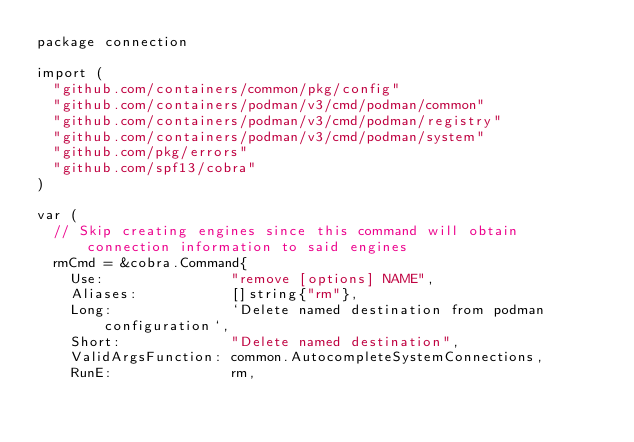<code> <loc_0><loc_0><loc_500><loc_500><_Go_>package connection

import (
	"github.com/containers/common/pkg/config"
	"github.com/containers/podman/v3/cmd/podman/common"
	"github.com/containers/podman/v3/cmd/podman/registry"
	"github.com/containers/podman/v3/cmd/podman/system"
	"github.com/pkg/errors"
	"github.com/spf13/cobra"
)

var (
	// Skip creating engines since this command will obtain connection information to said engines
	rmCmd = &cobra.Command{
		Use:               "remove [options] NAME",
		Aliases:           []string{"rm"},
		Long:              `Delete named destination from podman configuration`,
		Short:             "Delete named destination",
		ValidArgsFunction: common.AutocompleteSystemConnections,
		RunE:              rm,</code> 